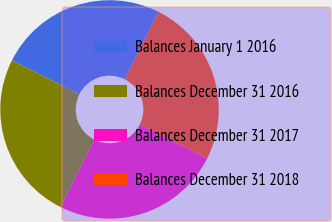Convert chart to OTSL. <chart><loc_0><loc_0><loc_500><loc_500><pie_chart><fcel>Balances January 1 2016<fcel>Balances December 31 2016<fcel>Balances December 31 2017<fcel>Balances December 31 2018<nl><fcel>25.0%<fcel>25.0%<fcel>25.0%<fcel>25.0%<nl></chart> 